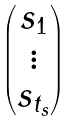Convert formula to latex. <formula><loc_0><loc_0><loc_500><loc_500>\begin{pmatrix} s _ { 1 } \\ \vdots \\ s _ { t _ { s } } \end{pmatrix}</formula> 